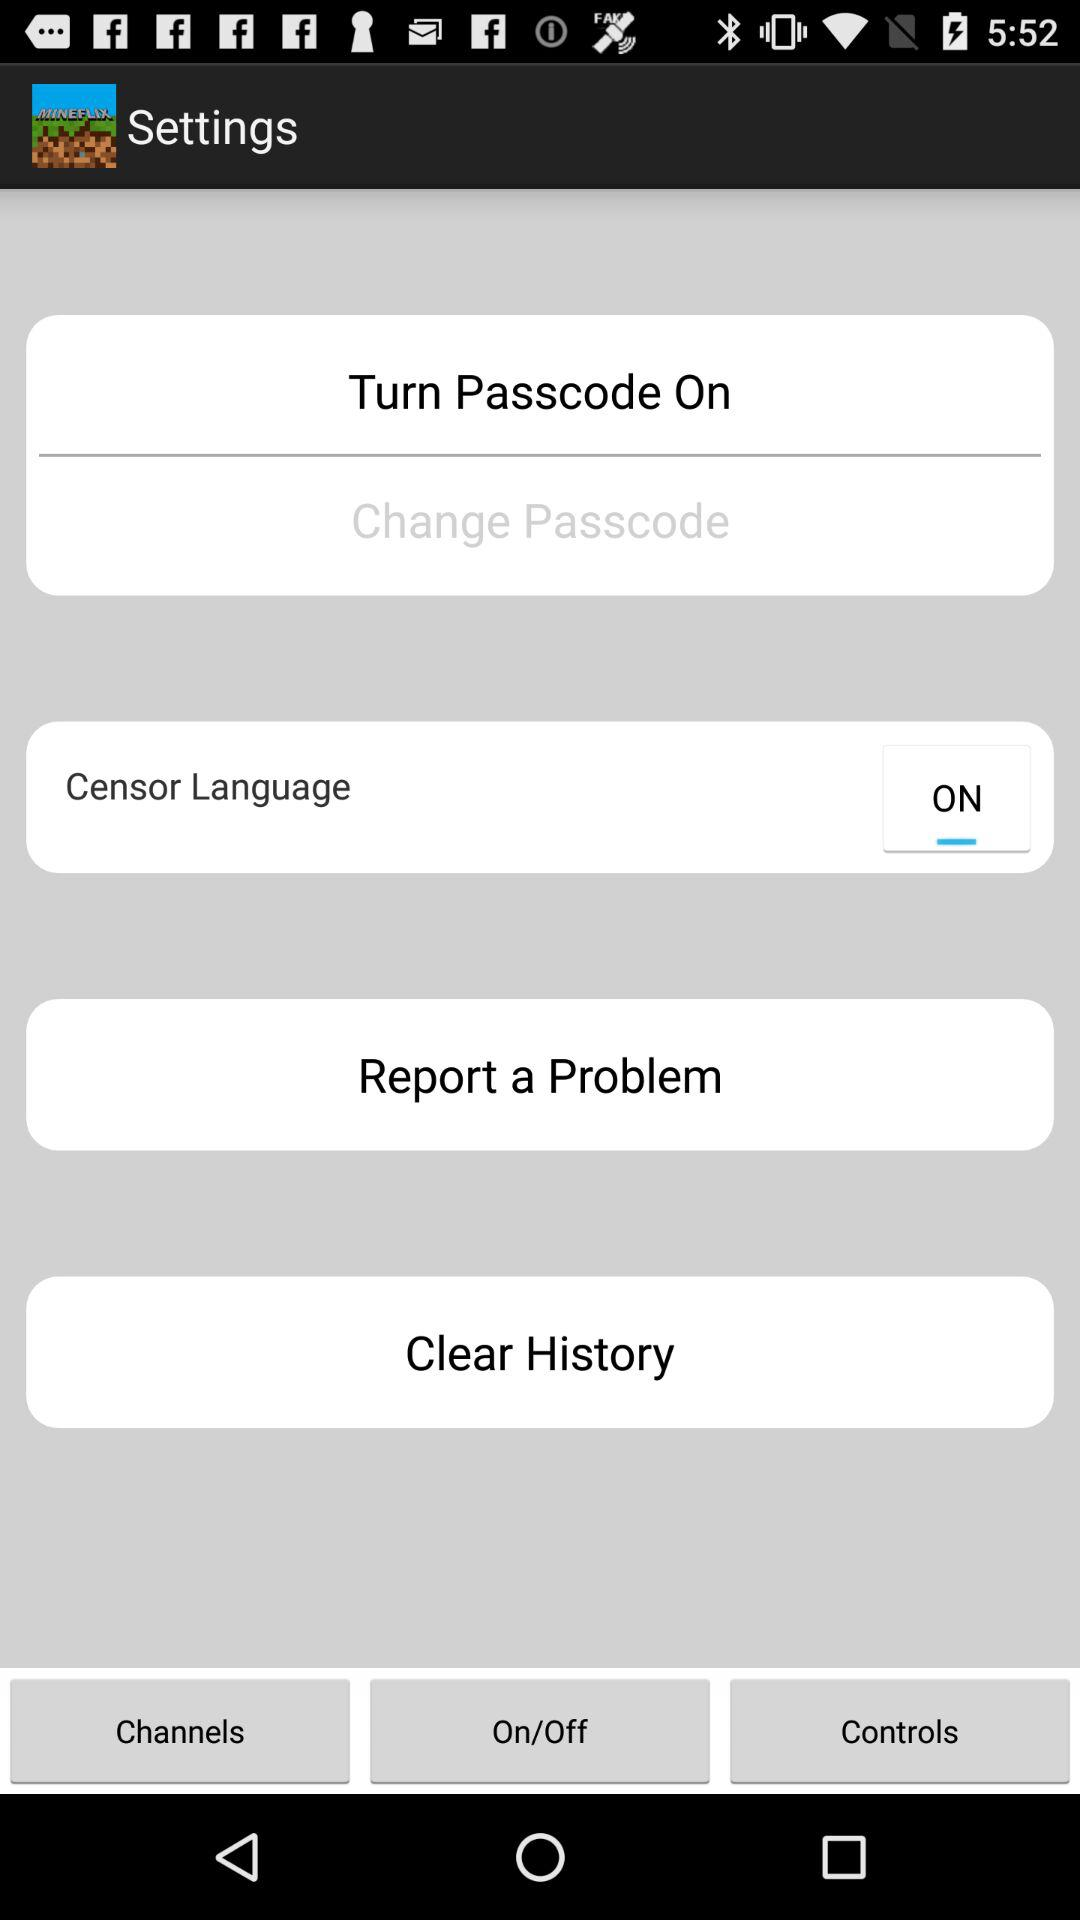What is the status of "Censor Language"? The status is on. 